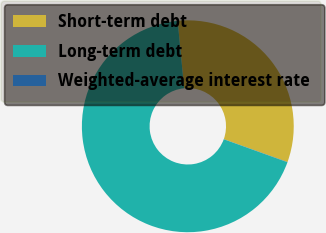Convert chart. <chart><loc_0><loc_0><loc_500><loc_500><pie_chart><fcel>Short-term debt<fcel>Long-term debt<fcel>Weighted-average interest rate<nl><fcel>32.01%<fcel>67.96%<fcel>0.03%<nl></chart> 